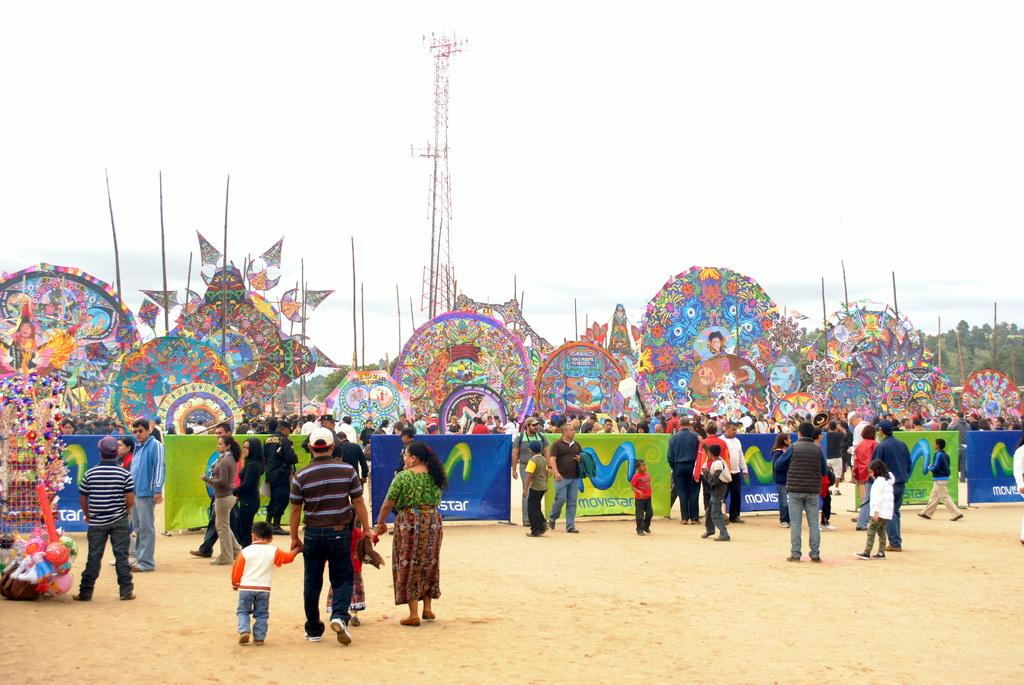How many people are in the group visible in the image? There is a group of people in the image, but the exact number cannot be determined from the provided facts. What type of objects can be seen with designs in the image? There are designed boards in the image. What type of signage is present in the image? There are banners in the image. What type of objects can be seen that are typically used for play? There are toys in the image. What type of vertical structures are present in the image? There are poles in the image. What type of natural vegetation is present in the image? There are trees in the image. What type of tall structure is present in the image? There is a tower in the image. What is visible in the background of the image? The sky is visible in the background of the image. Where is the faucet located in the image? There is no faucet present in the image. What type of geographical information can be seen on the map in the image? There is no map present in the image. What type of container is used for drinking in the image? There is no glass present in the image. 